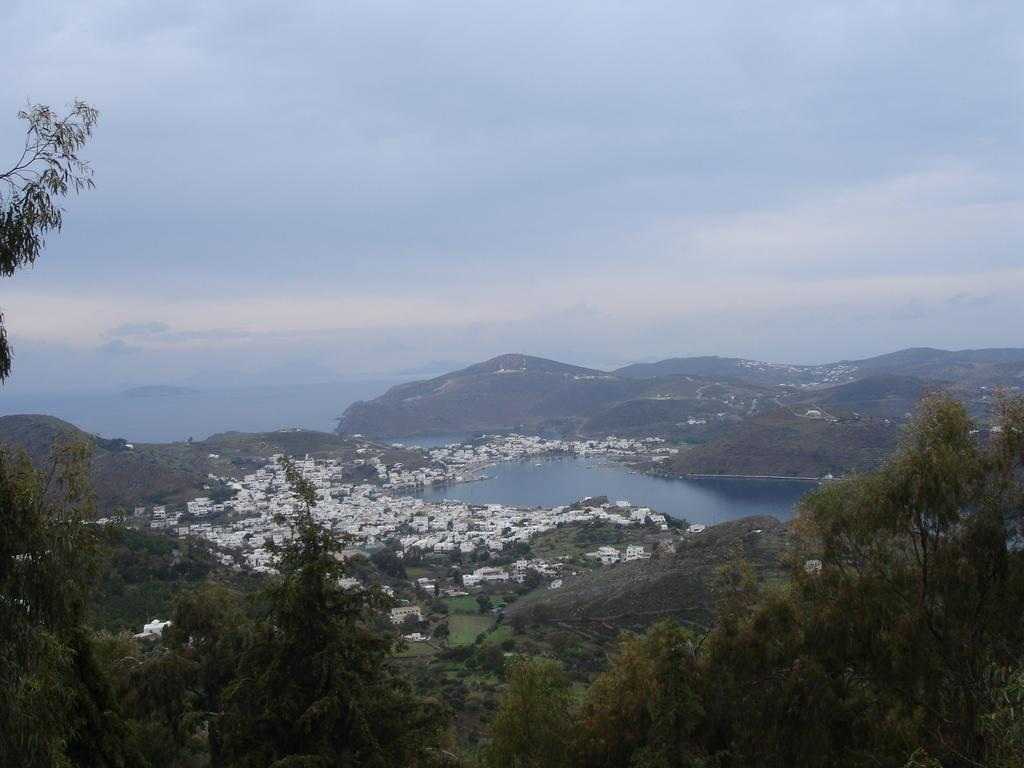What type of structures can be seen in the image? There is a group of buildings in the image. What natural elements are present in the image? There is a group of trees and a large water body in the image. What type of geographical feature can be seen in the image? There are hills visible in the image. What is the condition of the sky in the image? The sky is visible in the image and appears cloudy. Where is the lawyer sitting at the desk in the image? There is no lawyer or desk present in the image. 